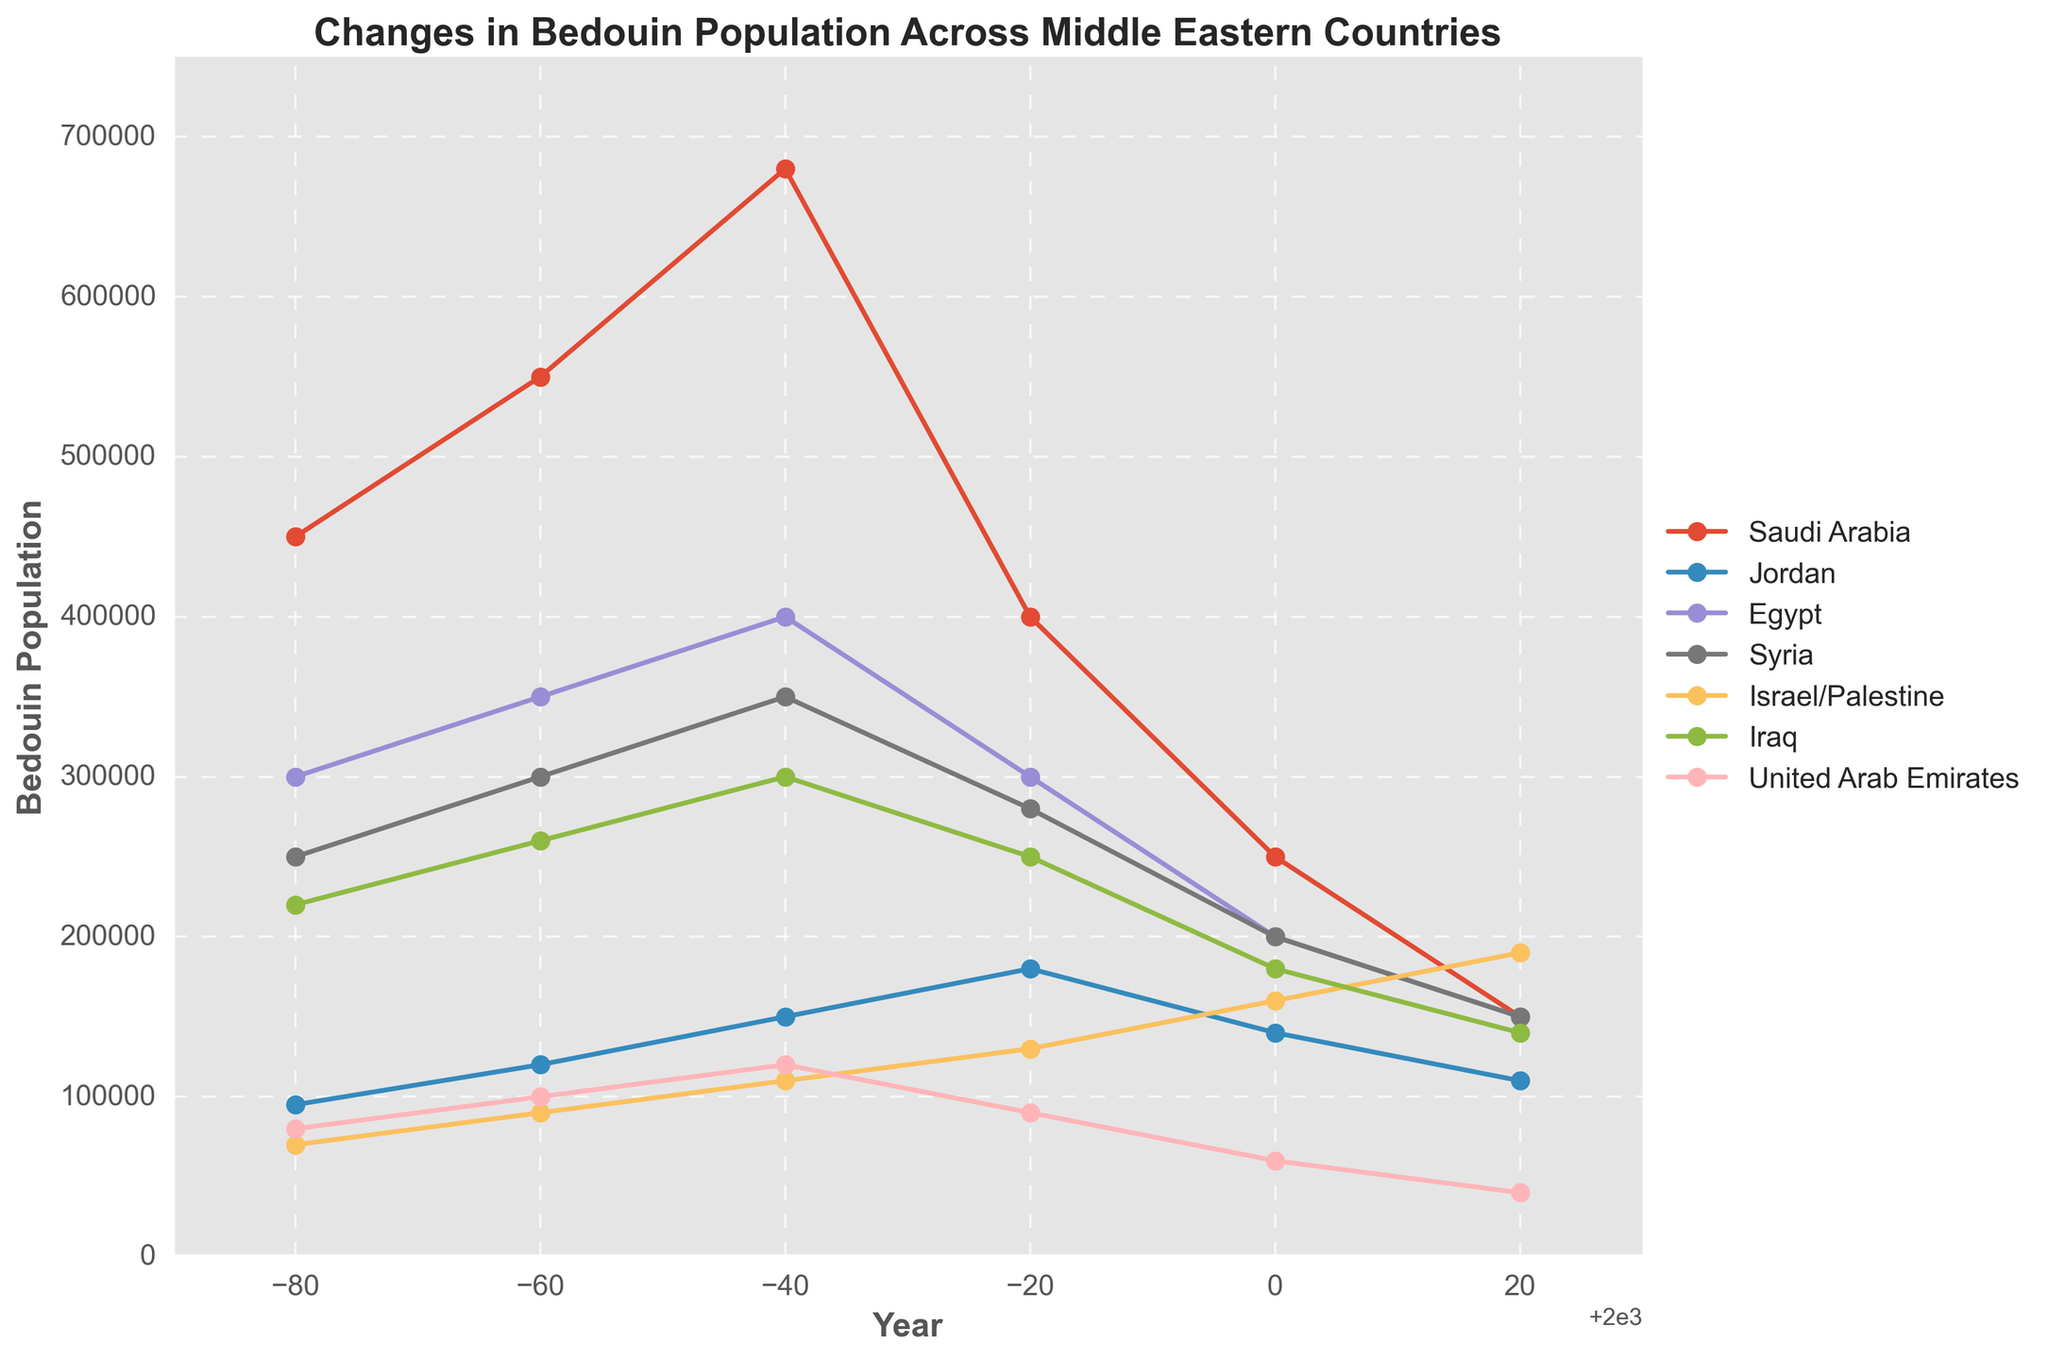Which country had the highest Bedouin population in 1920? To determine this, compare the Bedouin population values for each country in 1920. Saudi Arabia has the highest value at 450,000.
Answer: Saudi Arabia By how much did the Bedouin population in Saudi Arabia decrease from 1920 to 2020? First, find the population of Bedouins in Saudi Arabia in 1920 and 2020. Subtract the 2020 value from the 1920 value: 450,000 - 150,000 = 300,000.
Answer: 300,000 Which two countries had the closest Bedouin population in 2020? Compare the 2020 Bedouin populations of all the countries: Saudi Arabia (150,000), Jordan (110,000), Egypt (150,000), Syria (150,000), Israel/Palestine (190,000), Iraq (140,000), UAE (40,000). Syria and Egypt both have the same population of 150,000 each.
Answer: Syria and Egypt What is the average Bedouin population in Egypt across the years provided? Sum the Bedouin population values for Egypt across all years and divide by the number of years. (300,000 + 350,000 + 400,000 + 300,000 + 200,000 + 150,000) / 6 = 1,700,000 / 6 = approximately 283,333.
Answer: 283,333 Which country showed the most consistent Bedouin population change (least volatility) over the years? Visually inspect the linechart to identify the flattest line, indicating least volatility. Israel/Palestine shows a steadily increasing population with minimal fluctuation compared to other countries.
Answer: Israel/Palestine From 1940 to 1980, which country had the highest average Bedouin population? Calculate the average population for each country from 1940 to 1980 and compare: Saudi Arabia (550,000+680,000+400,000)/3=543,333, Jordan (120,000+150,000+180,000)/3=150,000, Egypt (350,000+400,000+300,000)/3=350,000, Syria (300,000+350,000+280,000)/3=310,000, Israel/Palestine (90,000+110,000+130,000)/3=110,000, Iraq (260,000+300,000+250,000)/3=270,000, UAE (100,000+120,000+90,000)/3=103,333. Saudi Arabia has the highest average.
Answer: Saudi Arabia What is the percent decrease in Bedouin population in UAE from 1940 to 2020? The population in the UAE was 100,000 in 1940 and decreased to 40,000 in 2020. Calculate the percent decrease: ((100,000 - 40,000) / 100,000) * 100 = 60%.
Answer: 60% Which decade experienced the steepest decline in Bedouin population in Saudi Arabia? Examine the slope of the line for each decade. Saudi Arabia's largest population drop appears between 1960 and 1980.
Answer: 1960 to 1980 How did the Bedouin population trend in Jordan compare to Syria from 1960 to 2020? Compare the trends visually over these years. Both countries show a general decline, but Syria shows more volatility especially during the 1980s.
Answer: Both declined; Syria was more volatile What is the combined population of Bedouins in Saudi Arabia and Iraq in 2020? Add the 2020 values for Saudi Arabia and Iraq: 150,000 + 140,000 = 290,000.
Answer: 290,000 